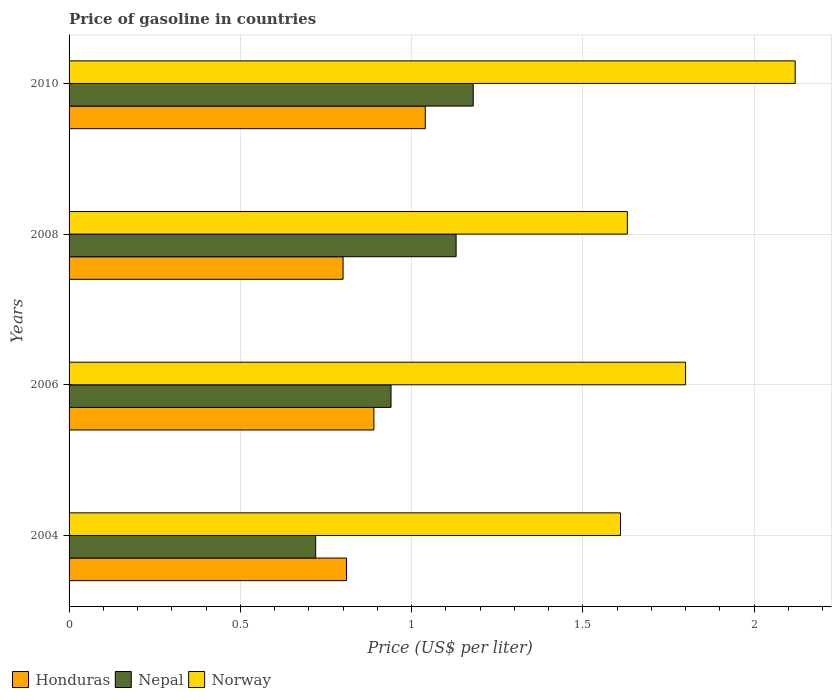How many different coloured bars are there?
Your answer should be very brief. 3. How many groups of bars are there?
Your response must be concise. 4. Are the number of bars per tick equal to the number of legend labels?
Provide a short and direct response. Yes. Are the number of bars on each tick of the Y-axis equal?
Offer a very short reply. Yes. How many bars are there on the 4th tick from the top?
Offer a terse response. 3. How many bars are there on the 2nd tick from the bottom?
Offer a terse response. 3. What is the label of the 1st group of bars from the top?
Your answer should be very brief. 2010. Across all years, what is the maximum price of gasoline in Nepal?
Offer a very short reply. 1.18. What is the total price of gasoline in Nepal in the graph?
Give a very brief answer. 3.97. What is the difference between the price of gasoline in Norway in 2004 and that in 2006?
Provide a short and direct response. -0.19. What is the difference between the price of gasoline in Nepal in 2010 and the price of gasoline in Norway in 2008?
Your answer should be very brief. -0.45. What is the average price of gasoline in Nepal per year?
Provide a succinct answer. 0.99. In the year 2004, what is the difference between the price of gasoline in Nepal and price of gasoline in Norway?
Your answer should be compact. -0.89. What is the ratio of the price of gasoline in Norway in 2004 to that in 2010?
Your answer should be very brief. 0.76. Is the price of gasoline in Honduras in 2006 less than that in 2010?
Keep it short and to the point. Yes. Is the difference between the price of gasoline in Nepal in 2008 and 2010 greater than the difference between the price of gasoline in Norway in 2008 and 2010?
Offer a very short reply. Yes. What is the difference between the highest and the second highest price of gasoline in Norway?
Your response must be concise. 0.32. What is the difference between the highest and the lowest price of gasoline in Norway?
Give a very brief answer. 0.51. What does the 3rd bar from the bottom in 2008 represents?
Your answer should be very brief. Norway. Are the values on the major ticks of X-axis written in scientific E-notation?
Offer a very short reply. No. Does the graph contain grids?
Ensure brevity in your answer.  Yes. How many legend labels are there?
Your answer should be compact. 3. How are the legend labels stacked?
Your answer should be very brief. Horizontal. What is the title of the graph?
Give a very brief answer. Price of gasoline in countries. Does "High income" appear as one of the legend labels in the graph?
Give a very brief answer. No. What is the label or title of the X-axis?
Ensure brevity in your answer.  Price (US$ per liter). What is the Price (US$ per liter) of Honduras in 2004?
Provide a short and direct response. 0.81. What is the Price (US$ per liter) of Nepal in 2004?
Your answer should be compact. 0.72. What is the Price (US$ per liter) of Norway in 2004?
Provide a succinct answer. 1.61. What is the Price (US$ per liter) in Honduras in 2006?
Make the answer very short. 0.89. What is the Price (US$ per liter) of Norway in 2006?
Provide a short and direct response. 1.8. What is the Price (US$ per liter) of Nepal in 2008?
Your answer should be compact. 1.13. What is the Price (US$ per liter) in Norway in 2008?
Give a very brief answer. 1.63. What is the Price (US$ per liter) of Nepal in 2010?
Ensure brevity in your answer.  1.18. What is the Price (US$ per liter) of Norway in 2010?
Your answer should be very brief. 2.12. Across all years, what is the maximum Price (US$ per liter) in Nepal?
Make the answer very short. 1.18. Across all years, what is the maximum Price (US$ per liter) of Norway?
Make the answer very short. 2.12. Across all years, what is the minimum Price (US$ per liter) of Nepal?
Offer a very short reply. 0.72. Across all years, what is the minimum Price (US$ per liter) of Norway?
Make the answer very short. 1.61. What is the total Price (US$ per liter) in Honduras in the graph?
Provide a succinct answer. 3.54. What is the total Price (US$ per liter) in Nepal in the graph?
Ensure brevity in your answer.  3.97. What is the total Price (US$ per liter) in Norway in the graph?
Offer a terse response. 7.16. What is the difference between the Price (US$ per liter) in Honduras in 2004 and that in 2006?
Your answer should be very brief. -0.08. What is the difference between the Price (US$ per liter) of Nepal in 2004 and that in 2006?
Ensure brevity in your answer.  -0.22. What is the difference between the Price (US$ per liter) in Norway in 2004 and that in 2006?
Make the answer very short. -0.19. What is the difference between the Price (US$ per liter) of Nepal in 2004 and that in 2008?
Your answer should be compact. -0.41. What is the difference between the Price (US$ per liter) of Norway in 2004 and that in 2008?
Make the answer very short. -0.02. What is the difference between the Price (US$ per liter) of Honduras in 2004 and that in 2010?
Ensure brevity in your answer.  -0.23. What is the difference between the Price (US$ per liter) of Nepal in 2004 and that in 2010?
Ensure brevity in your answer.  -0.46. What is the difference between the Price (US$ per liter) in Norway in 2004 and that in 2010?
Your response must be concise. -0.51. What is the difference between the Price (US$ per liter) of Honduras in 2006 and that in 2008?
Offer a terse response. 0.09. What is the difference between the Price (US$ per liter) of Nepal in 2006 and that in 2008?
Offer a very short reply. -0.19. What is the difference between the Price (US$ per liter) in Norway in 2006 and that in 2008?
Your answer should be compact. 0.17. What is the difference between the Price (US$ per liter) of Honduras in 2006 and that in 2010?
Provide a short and direct response. -0.15. What is the difference between the Price (US$ per liter) of Nepal in 2006 and that in 2010?
Your answer should be compact. -0.24. What is the difference between the Price (US$ per liter) in Norway in 2006 and that in 2010?
Your answer should be compact. -0.32. What is the difference between the Price (US$ per liter) of Honduras in 2008 and that in 2010?
Your response must be concise. -0.24. What is the difference between the Price (US$ per liter) of Norway in 2008 and that in 2010?
Your answer should be compact. -0.49. What is the difference between the Price (US$ per liter) of Honduras in 2004 and the Price (US$ per liter) of Nepal in 2006?
Give a very brief answer. -0.13. What is the difference between the Price (US$ per liter) of Honduras in 2004 and the Price (US$ per liter) of Norway in 2006?
Offer a very short reply. -0.99. What is the difference between the Price (US$ per liter) of Nepal in 2004 and the Price (US$ per liter) of Norway in 2006?
Offer a very short reply. -1.08. What is the difference between the Price (US$ per liter) of Honduras in 2004 and the Price (US$ per liter) of Nepal in 2008?
Ensure brevity in your answer.  -0.32. What is the difference between the Price (US$ per liter) of Honduras in 2004 and the Price (US$ per liter) of Norway in 2008?
Your answer should be very brief. -0.82. What is the difference between the Price (US$ per liter) of Nepal in 2004 and the Price (US$ per liter) of Norway in 2008?
Offer a very short reply. -0.91. What is the difference between the Price (US$ per liter) of Honduras in 2004 and the Price (US$ per liter) of Nepal in 2010?
Provide a succinct answer. -0.37. What is the difference between the Price (US$ per liter) of Honduras in 2004 and the Price (US$ per liter) of Norway in 2010?
Your response must be concise. -1.31. What is the difference between the Price (US$ per liter) of Nepal in 2004 and the Price (US$ per liter) of Norway in 2010?
Provide a succinct answer. -1.4. What is the difference between the Price (US$ per liter) of Honduras in 2006 and the Price (US$ per liter) of Nepal in 2008?
Provide a short and direct response. -0.24. What is the difference between the Price (US$ per liter) in Honduras in 2006 and the Price (US$ per liter) in Norway in 2008?
Provide a short and direct response. -0.74. What is the difference between the Price (US$ per liter) in Nepal in 2006 and the Price (US$ per liter) in Norway in 2008?
Offer a very short reply. -0.69. What is the difference between the Price (US$ per liter) in Honduras in 2006 and the Price (US$ per liter) in Nepal in 2010?
Provide a succinct answer. -0.29. What is the difference between the Price (US$ per liter) of Honduras in 2006 and the Price (US$ per liter) of Norway in 2010?
Provide a succinct answer. -1.23. What is the difference between the Price (US$ per liter) in Nepal in 2006 and the Price (US$ per liter) in Norway in 2010?
Provide a succinct answer. -1.18. What is the difference between the Price (US$ per liter) of Honduras in 2008 and the Price (US$ per liter) of Nepal in 2010?
Keep it short and to the point. -0.38. What is the difference between the Price (US$ per liter) in Honduras in 2008 and the Price (US$ per liter) in Norway in 2010?
Make the answer very short. -1.32. What is the difference between the Price (US$ per liter) in Nepal in 2008 and the Price (US$ per liter) in Norway in 2010?
Offer a very short reply. -0.99. What is the average Price (US$ per liter) of Honduras per year?
Offer a terse response. 0.89. What is the average Price (US$ per liter) in Norway per year?
Offer a terse response. 1.79. In the year 2004, what is the difference between the Price (US$ per liter) in Honduras and Price (US$ per liter) in Nepal?
Your response must be concise. 0.09. In the year 2004, what is the difference between the Price (US$ per liter) in Honduras and Price (US$ per liter) in Norway?
Offer a terse response. -0.8. In the year 2004, what is the difference between the Price (US$ per liter) of Nepal and Price (US$ per liter) of Norway?
Provide a short and direct response. -0.89. In the year 2006, what is the difference between the Price (US$ per liter) in Honduras and Price (US$ per liter) in Norway?
Keep it short and to the point. -0.91. In the year 2006, what is the difference between the Price (US$ per liter) of Nepal and Price (US$ per liter) of Norway?
Your answer should be compact. -0.86. In the year 2008, what is the difference between the Price (US$ per liter) of Honduras and Price (US$ per liter) of Nepal?
Your response must be concise. -0.33. In the year 2008, what is the difference between the Price (US$ per liter) in Honduras and Price (US$ per liter) in Norway?
Ensure brevity in your answer.  -0.83. In the year 2010, what is the difference between the Price (US$ per liter) of Honduras and Price (US$ per liter) of Nepal?
Make the answer very short. -0.14. In the year 2010, what is the difference between the Price (US$ per liter) of Honduras and Price (US$ per liter) of Norway?
Ensure brevity in your answer.  -1.08. In the year 2010, what is the difference between the Price (US$ per liter) in Nepal and Price (US$ per liter) in Norway?
Provide a short and direct response. -0.94. What is the ratio of the Price (US$ per liter) in Honduras in 2004 to that in 2006?
Give a very brief answer. 0.91. What is the ratio of the Price (US$ per liter) of Nepal in 2004 to that in 2006?
Provide a short and direct response. 0.77. What is the ratio of the Price (US$ per liter) of Norway in 2004 to that in 2006?
Offer a very short reply. 0.89. What is the ratio of the Price (US$ per liter) of Honduras in 2004 to that in 2008?
Offer a terse response. 1.01. What is the ratio of the Price (US$ per liter) of Nepal in 2004 to that in 2008?
Provide a succinct answer. 0.64. What is the ratio of the Price (US$ per liter) of Honduras in 2004 to that in 2010?
Give a very brief answer. 0.78. What is the ratio of the Price (US$ per liter) in Nepal in 2004 to that in 2010?
Keep it short and to the point. 0.61. What is the ratio of the Price (US$ per liter) in Norway in 2004 to that in 2010?
Offer a very short reply. 0.76. What is the ratio of the Price (US$ per liter) in Honduras in 2006 to that in 2008?
Offer a terse response. 1.11. What is the ratio of the Price (US$ per liter) of Nepal in 2006 to that in 2008?
Keep it short and to the point. 0.83. What is the ratio of the Price (US$ per liter) in Norway in 2006 to that in 2008?
Keep it short and to the point. 1.1. What is the ratio of the Price (US$ per liter) in Honduras in 2006 to that in 2010?
Your response must be concise. 0.86. What is the ratio of the Price (US$ per liter) of Nepal in 2006 to that in 2010?
Your response must be concise. 0.8. What is the ratio of the Price (US$ per liter) of Norway in 2006 to that in 2010?
Offer a very short reply. 0.85. What is the ratio of the Price (US$ per liter) of Honduras in 2008 to that in 2010?
Keep it short and to the point. 0.77. What is the ratio of the Price (US$ per liter) of Nepal in 2008 to that in 2010?
Your response must be concise. 0.96. What is the ratio of the Price (US$ per liter) in Norway in 2008 to that in 2010?
Your response must be concise. 0.77. What is the difference between the highest and the second highest Price (US$ per liter) in Honduras?
Provide a short and direct response. 0.15. What is the difference between the highest and the second highest Price (US$ per liter) of Nepal?
Provide a succinct answer. 0.05. What is the difference between the highest and the second highest Price (US$ per liter) in Norway?
Provide a succinct answer. 0.32. What is the difference between the highest and the lowest Price (US$ per liter) in Honduras?
Keep it short and to the point. 0.24. What is the difference between the highest and the lowest Price (US$ per liter) in Nepal?
Offer a very short reply. 0.46. What is the difference between the highest and the lowest Price (US$ per liter) in Norway?
Ensure brevity in your answer.  0.51. 